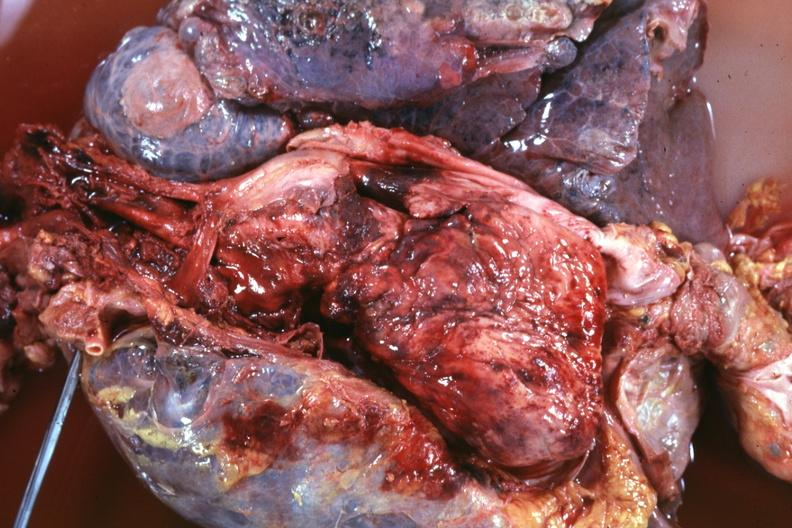what is present?
Answer the question using a single word or phrase. Thymus 